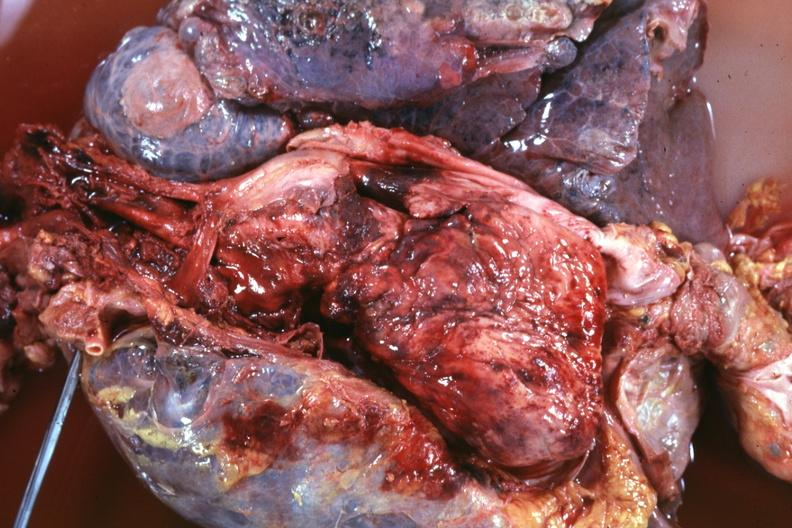what is present?
Answer the question using a single word or phrase. Thymus 